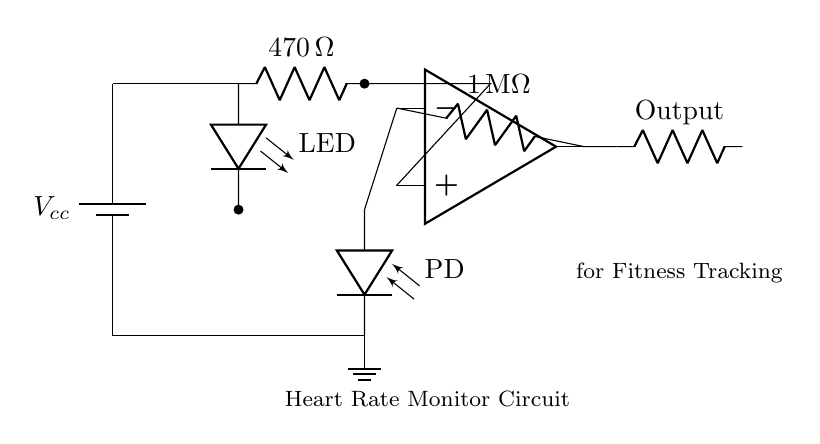What is the function of the LED in this circuit? The LED serves as the light source to illuminate the blood vessels, allowing the photodiode to detect changes in light absorption caused by the pulsing of blood, which corresponds to heartbeats.
Answer: Light source What is the value of the feedback resistor? The feedback resistor is used to determine the gain of the operational amplifier and it is labeled as one megaohm in the circuit diagram.
Answer: One megaohm How many main components are in this heart rate monitor circuit? The circuit includes five main components: a battery, an LED, a photodiode, an operational amplifier, and a feedback resistor.
Answer: Five What role does the photodiode play? The photodiode detects the intensity of light reflected from the skin's surface, converting light signals into electrical signals corresponding to heart rate.
Answer: Light detector What is the power supply voltage labeled as? The power supply voltage is indicated on the schematic as Vcc, which represents the connected voltage source for powering the circuit.
Answer: Vcc Why is a resistor used with the LED? The resistor limits the current flowing through the LED to prevent it from drawing too much current, which could damage it, ensuring it operates safely and effectively.
Answer: Current limitation 